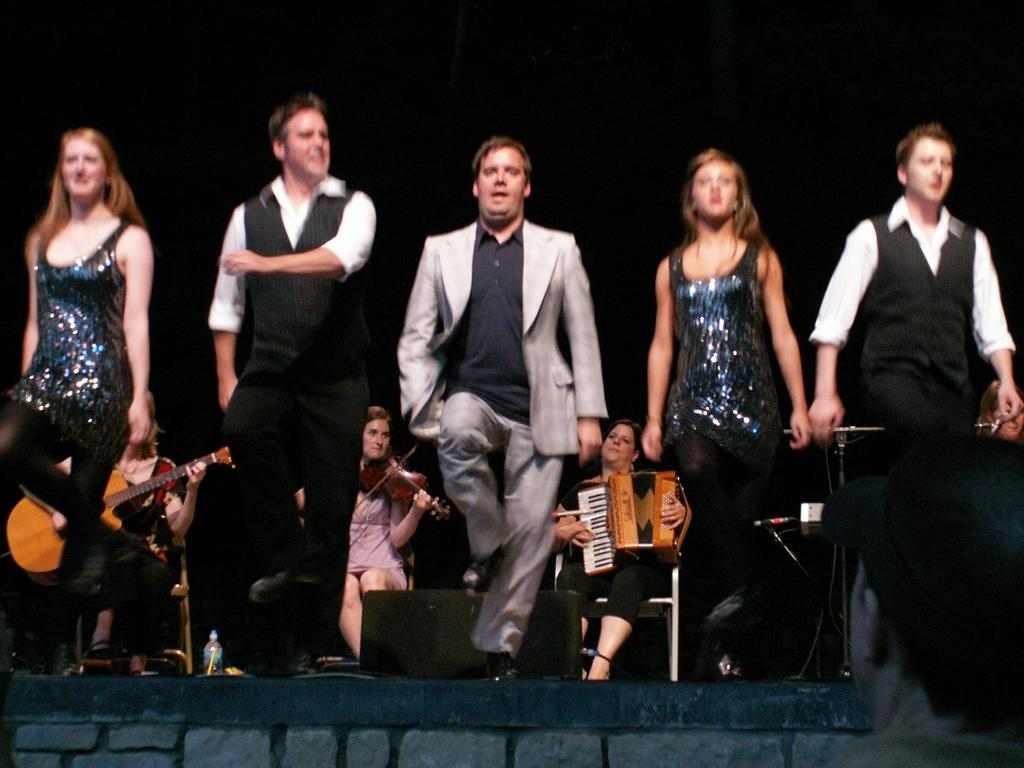What is happening in the image? There are people standing on a stage in the image. Where are the other people located in the image? There are people sitting at the back in the image. What are the people sitting at the back doing? The people sitting at the back are holding musical instruments. What type of soap is being sold at the market in the image? There is no market or soap present in the image; it features people standing on a stage and others sitting at the back holding musical instruments. How many light bulbs are visible in the image? There are no light bulbs visible in the image. 